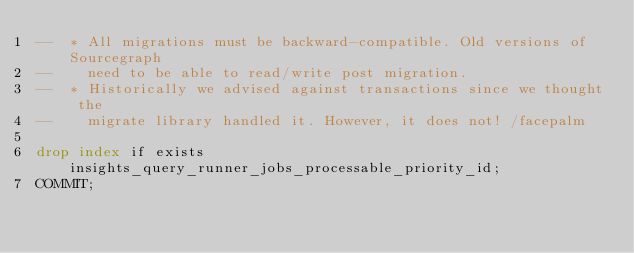<code> <loc_0><loc_0><loc_500><loc_500><_SQL_>--  * All migrations must be backward-compatible. Old versions of Sourcegraph
--    need to be able to read/write post migration.
--  * Historically we advised against transactions since we thought the
--    migrate library handled it. However, it does not! /facepalm

drop index if exists insights_query_runner_jobs_processable_priority_id;
COMMIT;
</code> 